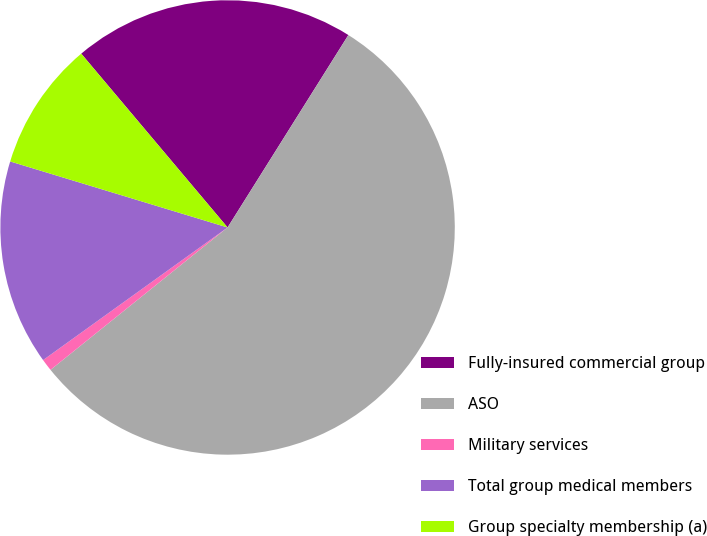<chart> <loc_0><loc_0><loc_500><loc_500><pie_chart><fcel>Fully-insured commercial group<fcel>ASO<fcel>Military services<fcel>Total group medical members<fcel>Group specialty membership (a)<nl><fcel>20.06%<fcel>55.3%<fcel>0.86%<fcel>14.61%<fcel>9.17%<nl></chart> 